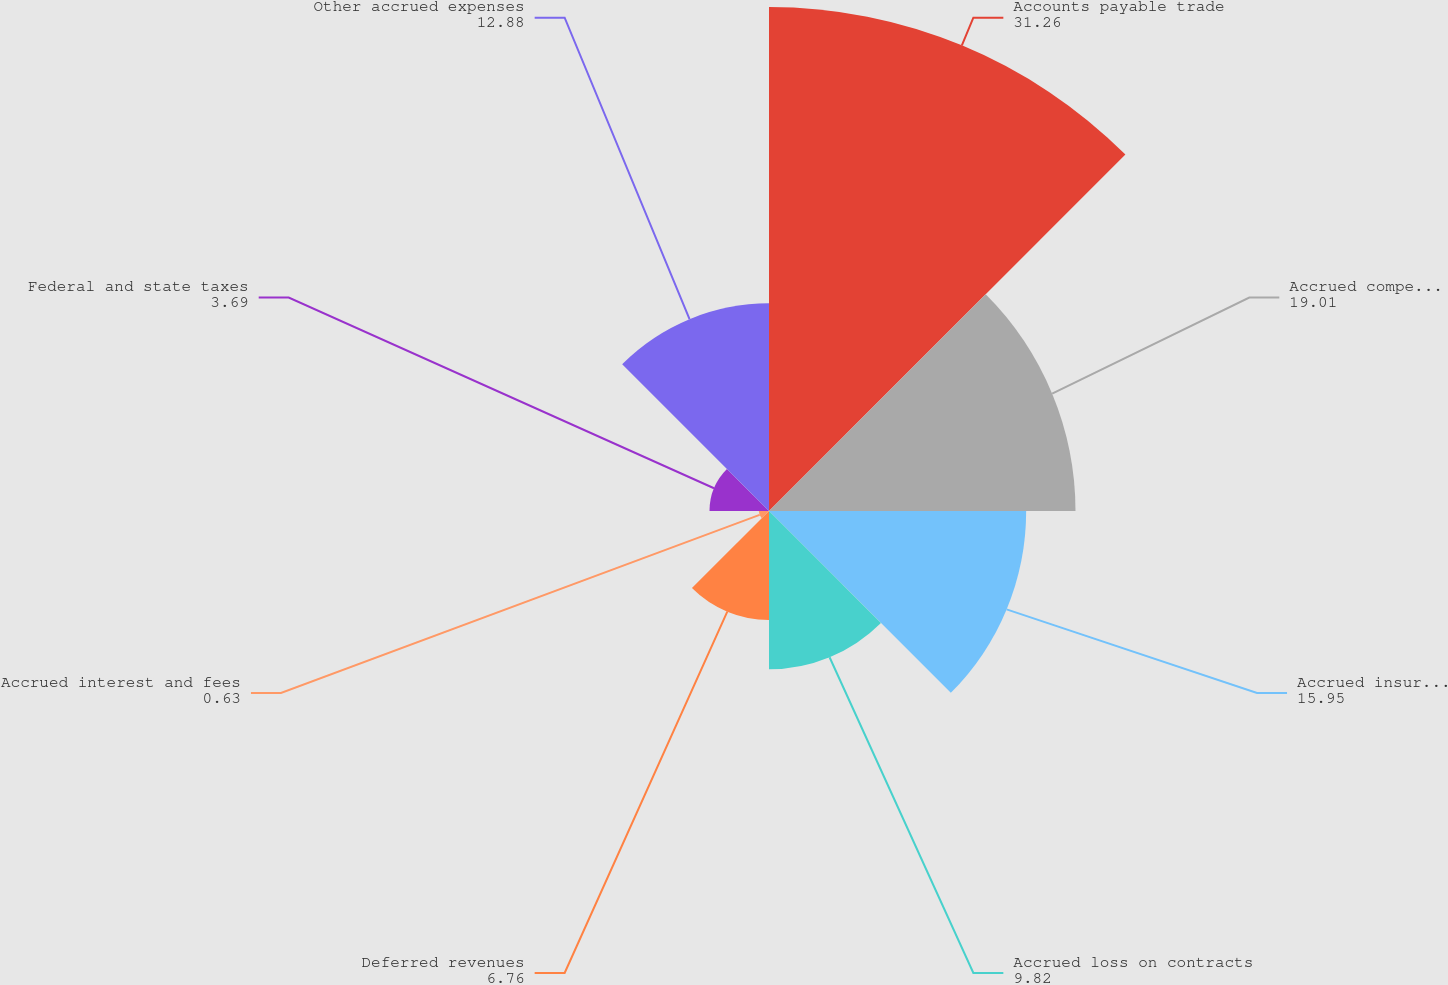Convert chart to OTSL. <chart><loc_0><loc_0><loc_500><loc_500><pie_chart><fcel>Accounts payable trade<fcel>Accrued compensation and<fcel>Accrued insurance<fcel>Accrued loss on contracts<fcel>Deferred revenues<fcel>Accrued interest and fees<fcel>Federal and state taxes<fcel>Other accrued expenses<nl><fcel>31.26%<fcel>19.01%<fcel>15.95%<fcel>9.82%<fcel>6.76%<fcel>0.63%<fcel>3.69%<fcel>12.88%<nl></chart> 